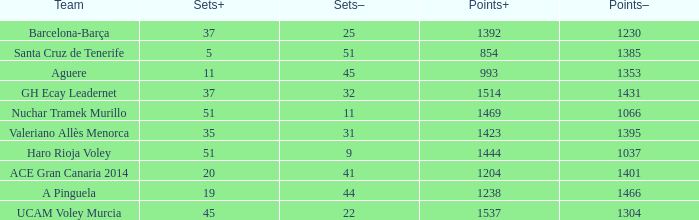What is the highest Points+ number that has a Sets+ number larger than 45, a Sets- number larger than 9, and a Points- number smaller than 1066? None. 